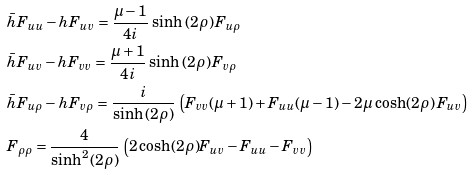Convert formula to latex. <formula><loc_0><loc_0><loc_500><loc_500>& \bar { h } F _ { u u } - h F _ { u v } = \frac { \mu - 1 } { 4 i } \, \sinh { ( 2 \rho ) } \, F _ { u \rho } \\ & \bar { h } F _ { u v } - h F _ { v v } = \frac { \mu + 1 } { 4 i } \, \sinh { ( 2 \rho ) } \, F _ { v \rho } \\ & \bar { h } F _ { u \rho } - h F _ { v \rho } = \frac { i } { \sinh { ( 2 \rho ) } } \, \left ( F _ { v v } ( \mu + 1 ) + F _ { u u } ( \mu - 1 ) - 2 \mu \, \cosh ( 2 \rho ) \, F _ { u v } \right ) \\ & F _ { \rho \rho } = \frac { 4 } { \sinh ^ { 2 } ( 2 \rho ) } \, \left ( 2 \cosh ( 2 \rho ) F _ { u v } - F _ { u u } - F _ { v v } \right )</formula> 